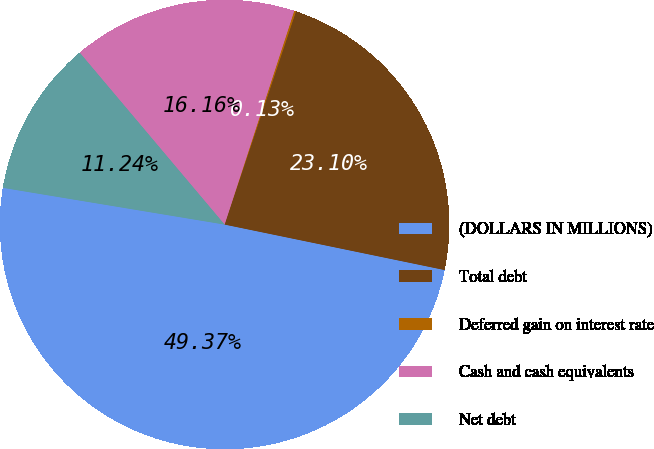Convert chart to OTSL. <chart><loc_0><loc_0><loc_500><loc_500><pie_chart><fcel>(DOLLARS IN MILLIONS)<fcel>Total debt<fcel>Deferred gain on interest rate<fcel>Cash and cash equivalents<fcel>Net debt<nl><fcel>49.37%<fcel>23.1%<fcel>0.13%<fcel>16.16%<fcel>11.24%<nl></chart> 